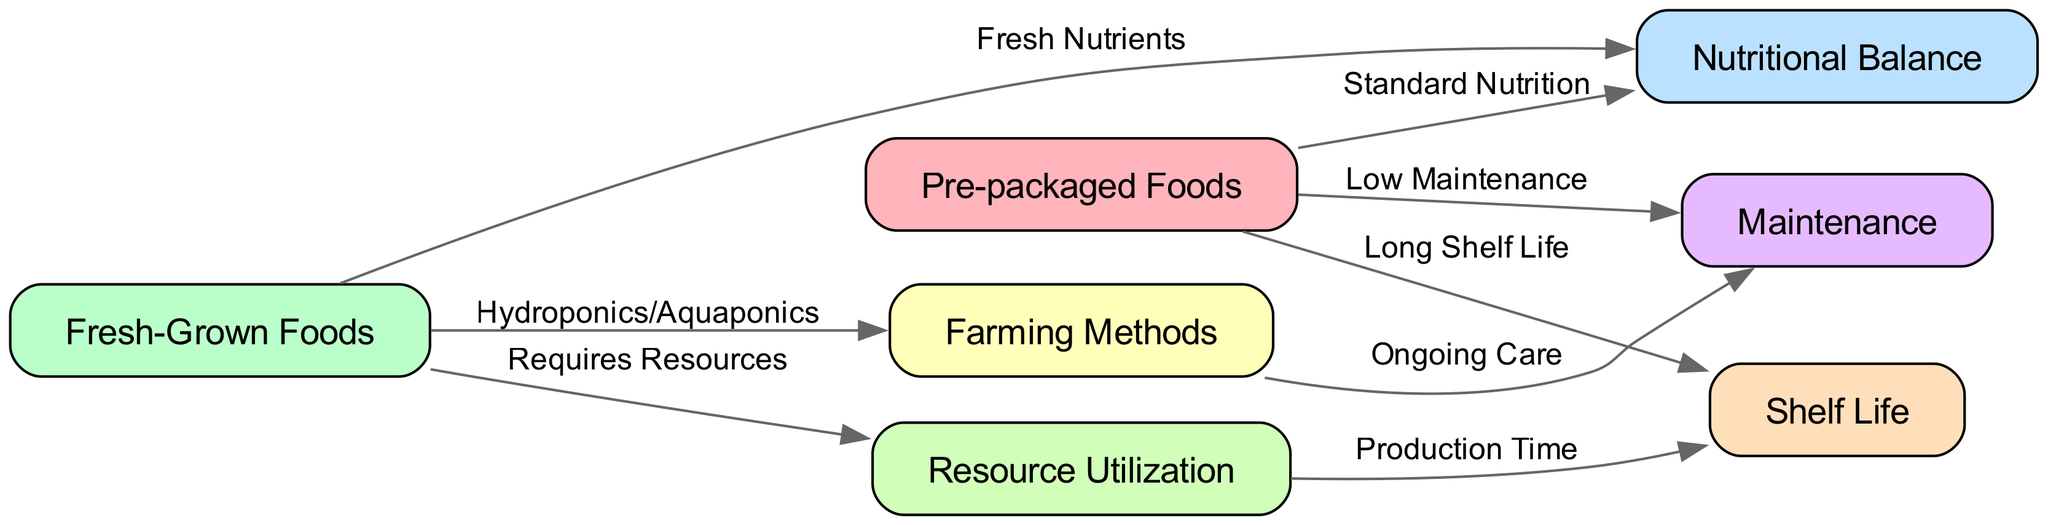What are the two types of food mentioned in the diagram? The diagram lists two types of food: Pre-packaged Foods and Fresh-Grown Foods. These are the primary nodes shown in the diagram.
Answer: Pre-packaged Foods, Fresh-Grown Foods How many edges are there in total? The diagram has a total of 8 edges connecting the nodes. Each connection represents a relationship between the food types and other relevant factors.
Answer: 8 What is the relationship label between Pre-packaged Foods and Nutritional Balance? The relationship from Pre-packaged Foods to Nutritional Balance is labeled "Standard Nutrition," indicating that this type of food provides a standard level of nutrition.
Answer: Standard Nutrition Which method is associated with Fresh-Grown Foods? The edge from Fresh-Grown Foods points to Farming Methods, which is labeled "Hydroponics/Aquaponics," indicating the methods used to grow these fresh foods.
Answer: Hydroponics/Aquaponics What does the relationship between Farming Methods and Maintenance entail? Farming Methods lead to Maintenance with the label "Ongoing Care," suggesting that using these methods requires continuous effort and attention for the plants to thrive.
Answer: Ongoing Care What do Pre-packaged Foods require regarding their maintenance? The edge from Pre-packaged Foods to Maintenance indicates "Low Maintenance," meaning that these foods do not need much ongoing effort to manage compared to fresh-grown options.
Answer: Low Maintenance How is the relationship between Resource Utilization and Shelf Life characterized? The edge from Resource Utilization to Shelf Life is labeled "Production Time," which indicates that the time taken to produce fresh-grown foods impacts their shelf life.
Answer: Production Time Which food option provides fresh nutrients? The relationship from Fresh-Grown Foods to Nutritional Balance is labeled "Fresh Nutrients," showing that this option provides more freshly sourced nutrients compared to pre-packaged foods.
Answer: Fresh Nutrients 